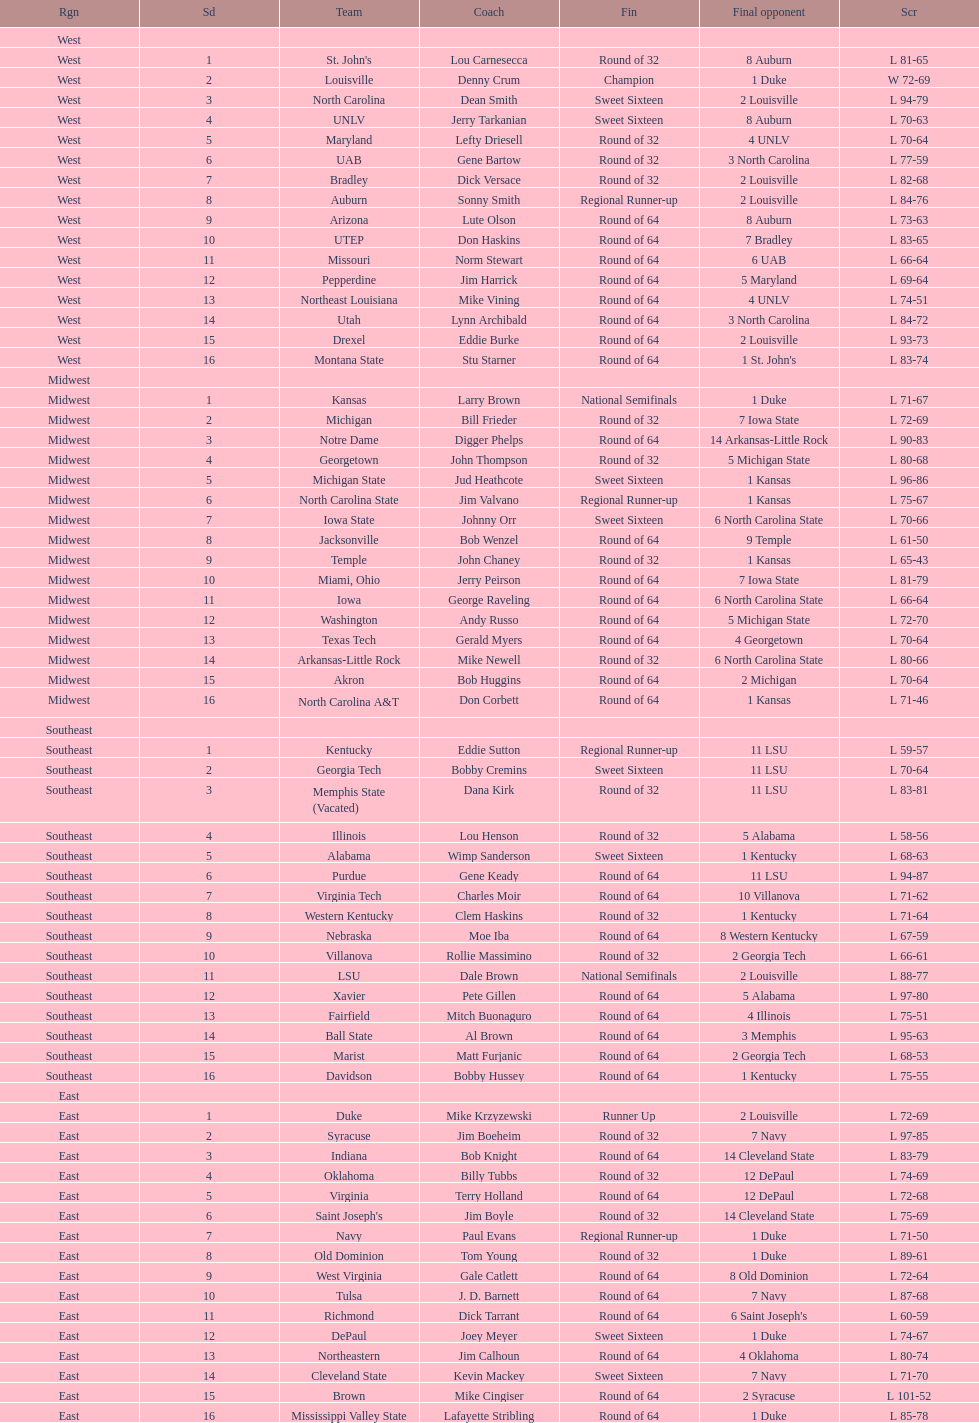How many teams are in the east region. 16. 